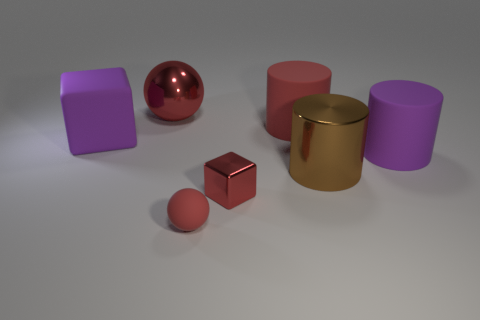There is a large red cylinder right of the tiny ball; what is it made of?
Your response must be concise. Rubber. Is the number of large blue matte balls greater than the number of cylinders?
Provide a short and direct response. No. How many things are big things that are on the right side of the shiny cube or big metallic objects?
Ensure brevity in your answer.  4. There is a big red object that is to the right of the small red shiny object; what number of big brown objects are on the left side of it?
Your response must be concise. 0. How big is the ball that is in front of the metallic thing that is behind the purple object that is left of the large red ball?
Keep it short and to the point. Small. There is a matte cylinder that is left of the purple cylinder; is it the same color as the tiny cube?
Your response must be concise. Yes. What is the size of the red metallic thing that is the same shape as the tiny matte object?
Your response must be concise. Large. What number of objects are objects on the left side of the big red rubber cylinder or purple rubber things on the right side of the metal sphere?
Provide a succinct answer. 5. The large purple rubber thing that is on the left side of the small red cube in front of the big red sphere is what shape?
Provide a short and direct response. Cube. Are there any other things that have the same color as the matte ball?
Offer a terse response. Yes. 